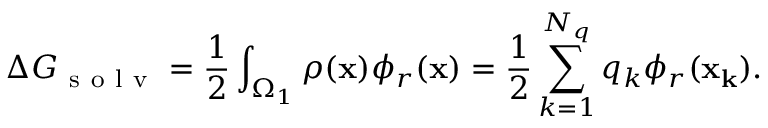<formula> <loc_0><loc_0><loc_500><loc_500>\Delta G _ { s o l v } = \frac { 1 } { 2 } \int _ { \Omega _ { 1 } } \rho ( x ) \phi _ { r } ( x ) = \frac { 1 } { 2 } \sum _ { k = 1 } ^ { N _ { q } } q _ { k } \phi _ { r } ( x _ { k } ) .</formula> 